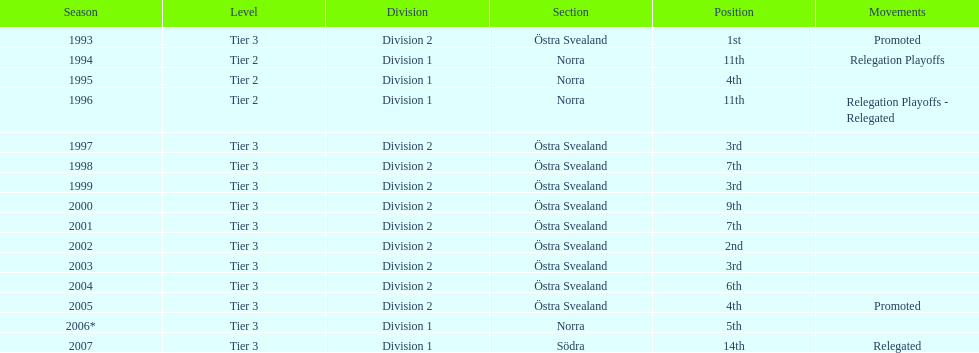In how many cases was norra noted as the section? 4. 